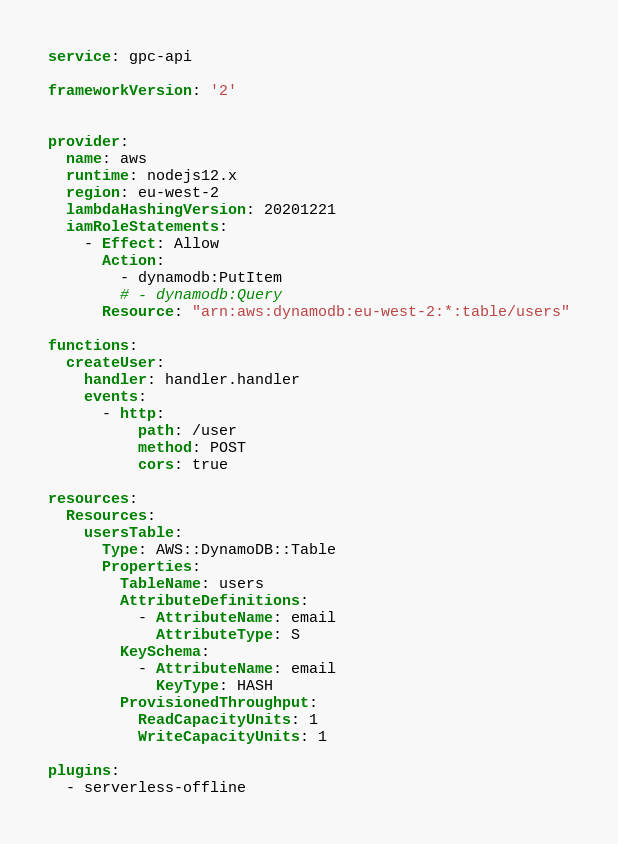<code> <loc_0><loc_0><loc_500><loc_500><_YAML_>service: gpc-api

frameworkVersion: '2'


provider:
  name: aws
  runtime: nodejs12.x
  region: eu-west-2
  lambdaHashingVersion: 20201221
  iamRoleStatements:
    - Effect: Allow
      Action:
        - dynamodb:PutItem
        # - dynamodb:Query
      Resource: "arn:aws:dynamodb:eu-west-2:*:table/users"

functions:
  createUser:
    handler: handler.handler
    events:
      - http:
          path: /user
          method: POST
          cors: true

resources:
  Resources:
    usersTable:
      Type: AWS::DynamoDB::Table
      Properties:
        TableName: users
        AttributeDefinitions:
          - AttributeName: email
            AttributeType: S
        KeySchema:
          - AttributeName: email
            KeyType: HASH
        ProvisionedThroughput:
          ReadCapacityUnits: 1
          WriteCapacityUnits: 1

plugins:
  - serverless-offline
</code> 